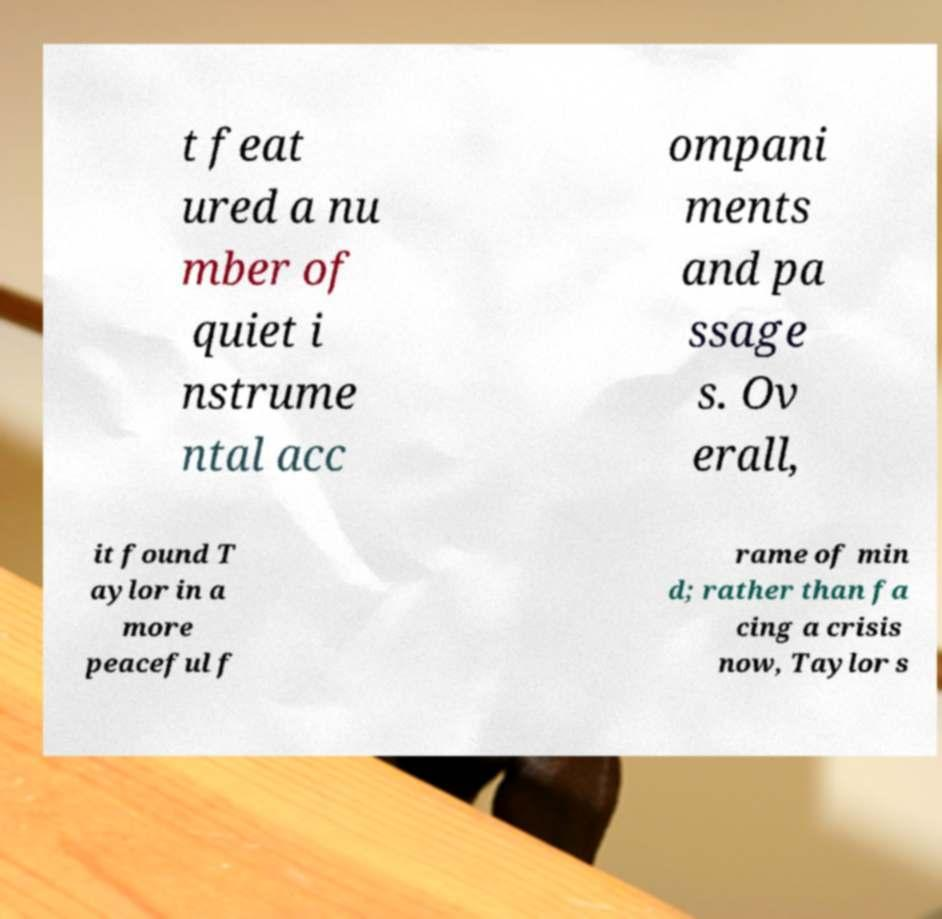For documentation purposes, I need the text within this image transcribed. Could you provide that? t feat ured a nu mber of quiet i nstrume ntal acc ompani ments and pa ssage s. Ov erall, it found T aylor in a more peaceful f rame of min d; rather than fa cing a crisis now, Taylor s 